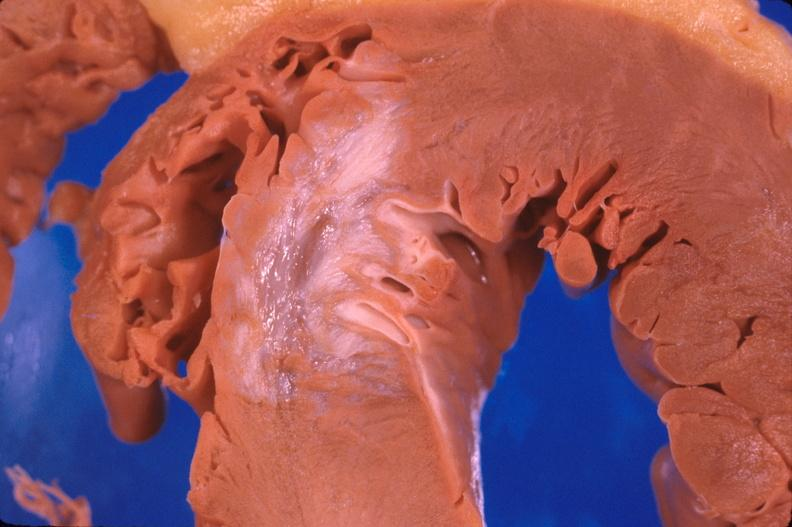does tuberculosis show heart, old myocardial infarction with fibrosis?
Answer the question using a single word or phrase. No 